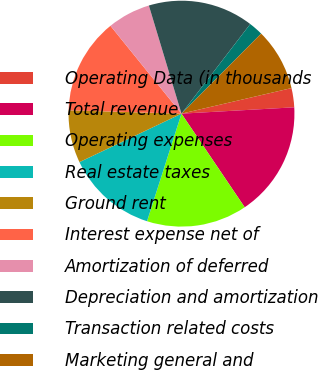Convert chart to OTSL. <chart><loc_0><loc_0><loc_500><loc_500><pie_chart><fcel>Operating Data (in thousands<fcel>Total revenue<fcel>Operating expenses<fcel>Real estate taxes<fcel>Ground rent<fcel>Interest expense net of<fcel>Amortization of deferred<fcel>Depreciation and amortization<fcel>Transaction related costs<fcel>Marketing general and<nl><fcel>2.74%<fcel>16.44%<fcel>14.38%<fcel>13.01%<fcel>7.53%<fcel>13.7%<fcel>6.16%<fcel>15.07%<fcel>2.05%<fcel>8.9%<nl></chart> 